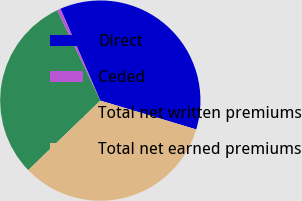Convert chart to OTSL. <chart><loc_0><loc_0><loc_500><loc_500><pie_chart><fcel>Direct<fcel>Ceded<fcel>Total net written premiums<fcel>Total net earned premiums<nl><fcel>36.16%<fcel>0.57%<fcel>30.13%<fcel>33.14%<nl></chart> 